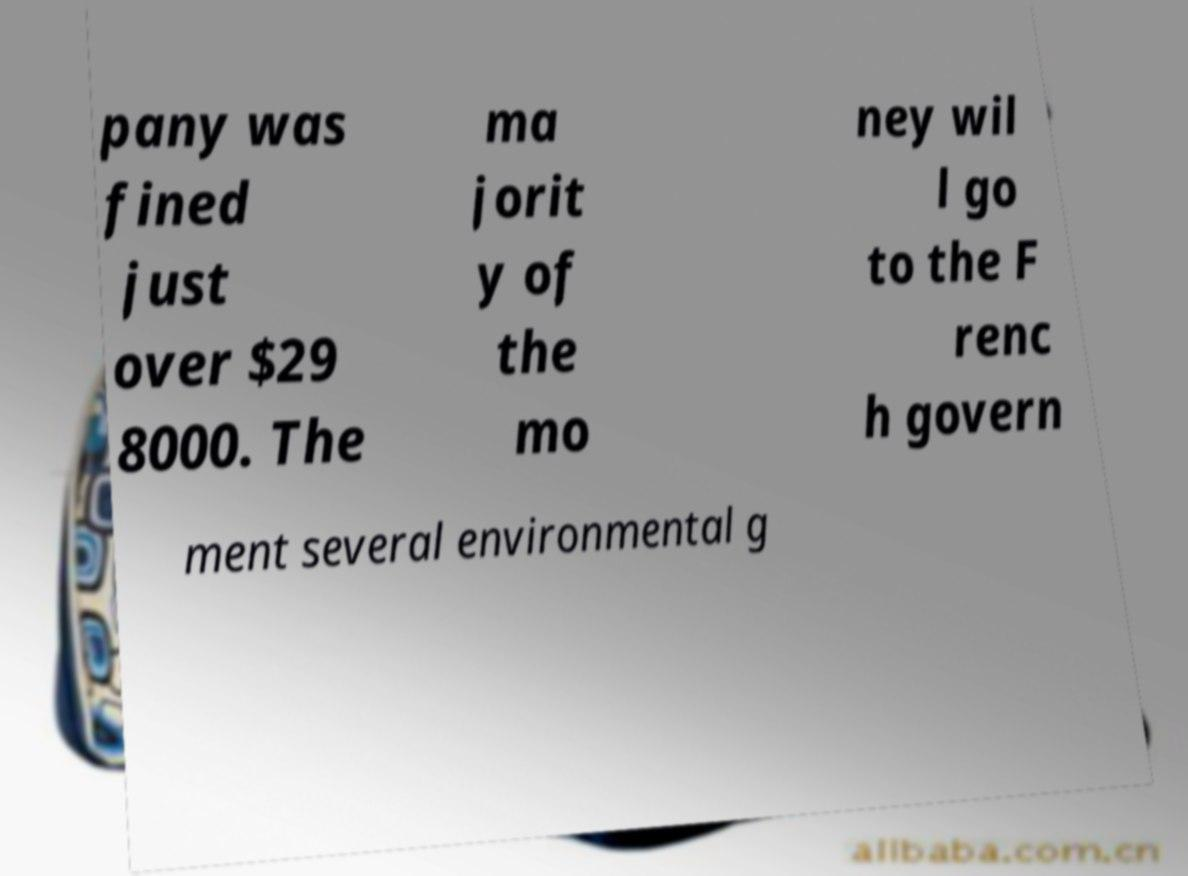What messages or text are displayed in this image? I need them in a readable, typed format. pany was fined just over $29 8000. The ma jorit y of the mo ney wil l go to the F renc h govern ment several environmental g 